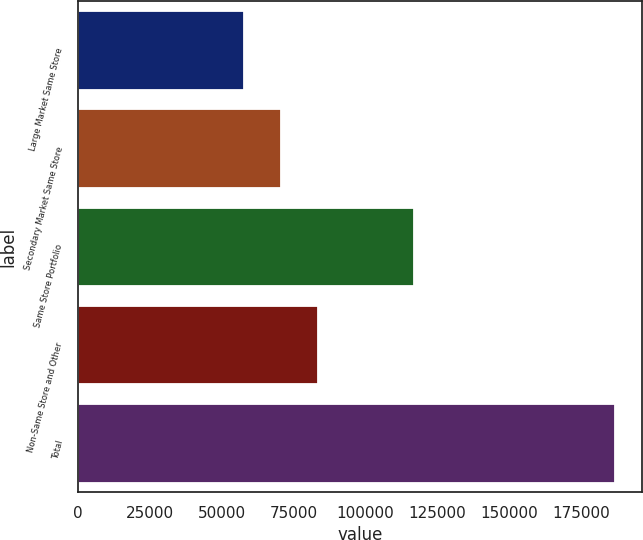Convert chart. <chart><loc_0><loc_0><loc_500><loc_500><bar_chart><fcel>Large Market Same Store<fcel>Secondary Market Same Store<fcel>Same Store Portfolio<fcel>Non-Same Store and Other<fcel>Total<nl><fcel>57712<fcel>70638.7<fcel>117051<fcel>83565.4<fcel>186979<nl></chart> 